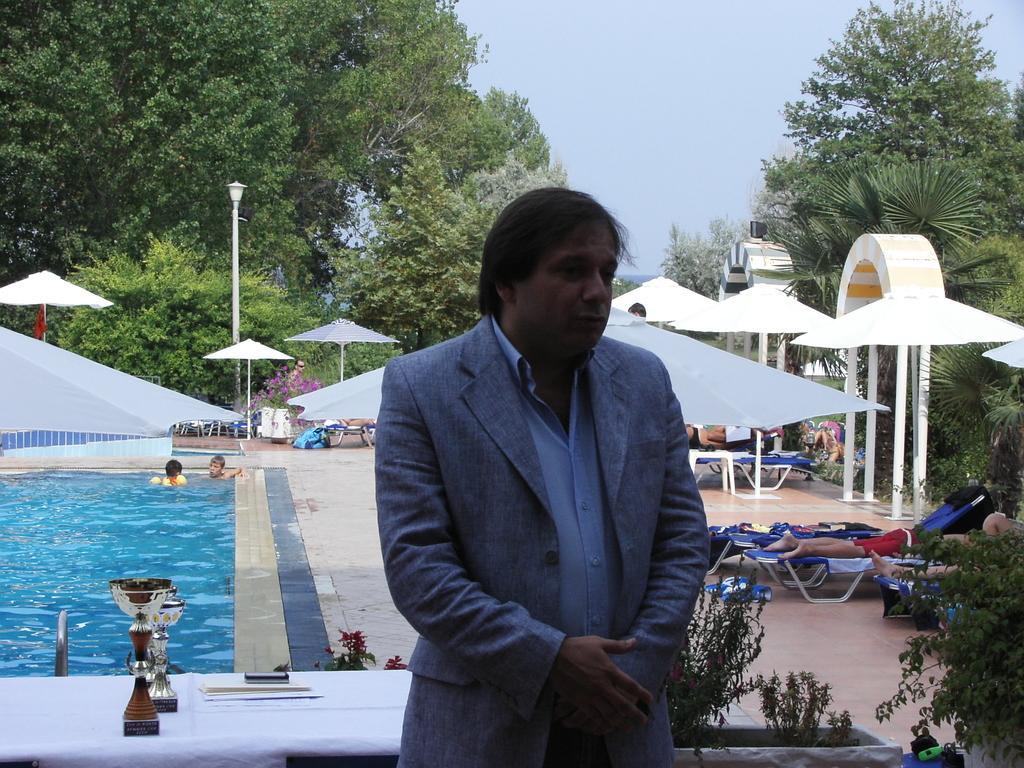How would you summarize this image in a sentence or two? In the foreground of the picture there are plants, desk, papers, cups and a person standing. On the right there are umbrellas, trees, arches, table, beach chairs and people. On the left there are umbrellas, people and a pool. In the background there are trees, lamp and sky. 